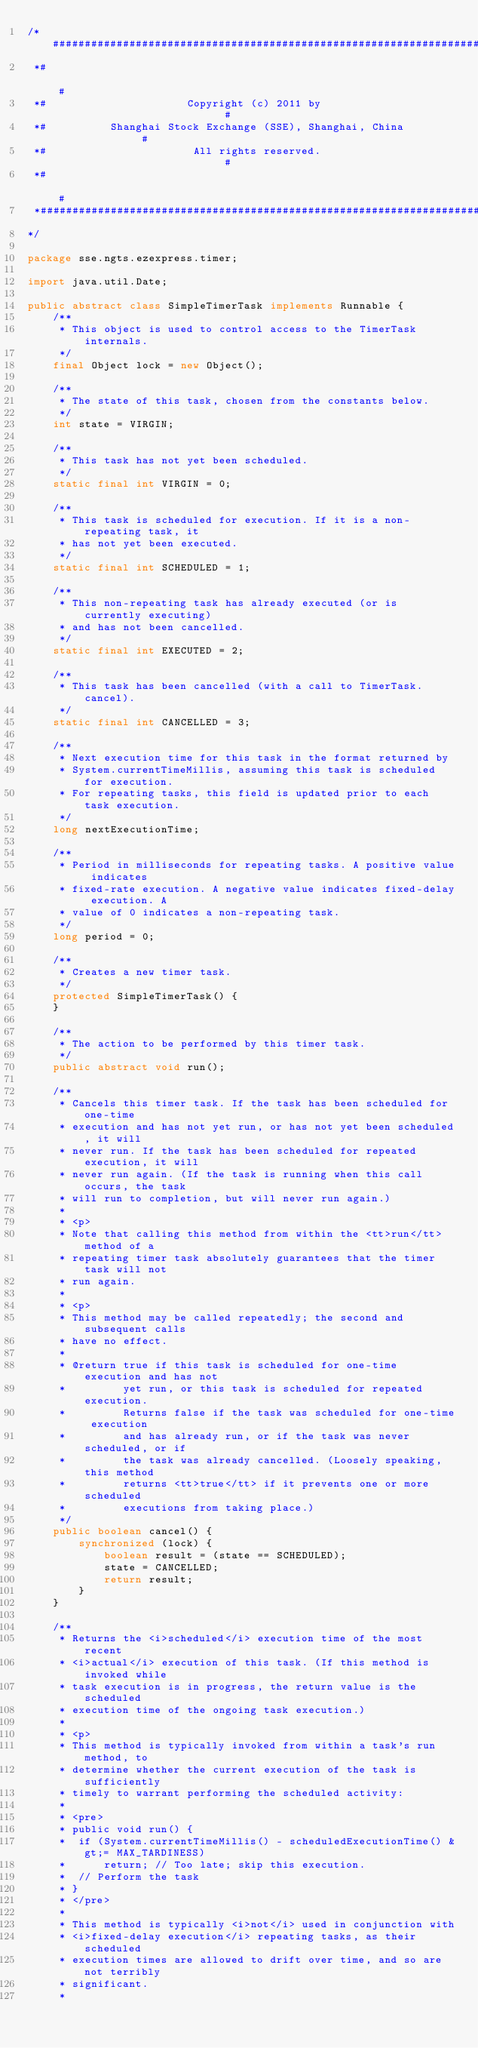<code> <loc_0><loc_0><loc_500><loc_500><_Java_>/*########################################################################
 *#                                                                      #
 *#                      Copyright (c) 2011 by                           #
 *#          Shanghai Stock Exchange (SSE), Shanghai, China              #
 *#                       All rights reserved.                           #
 *#                                                                      #
 *########################################################################
*/

package sse.ngts.ezexpress.timer;

import java.util.Date;

public abstract class SimpleTimerTask implements Runnable {
	/**
	 * This object is used to control access to the TimerTask internals.
	 */
	final Object lock = new Object();

	/**
	 * The state of this task, chosen from the constants below.
	 */
	int state = VIRGIN;

	/**
	 * This task has not yet been scheduled.
	 */
	static final int VIRGIN = 0;

	/**
	 * This task is scheduled for execution. If it is a non-repeating task, it
	 * has not yet been executed.
	 */
	static final int SCHEDULED = 1;

	/**
	 * This non-repeating task has already executed (or is currently executing)
	 * and has not been cancelled.
	 */
	static final int EXECUTED = 2;

	/**
	 * This task has been cancelled (with a call to TimerTask.cancel).
	 */
	static final int CANCELLED = 3;

	/**
	 * Next execution time for this task in the format returned by
	 * System.currentTimeMillis, assuming this task is scheduled for execution.
	 * For repeating tasks, this field is updated prior to each task execution.
	 */
	long nextExecutionTime;

	/**
	 * Period in milliseconds for repeating tasks. A positive value indicates
	 * fixed-rate execution. A negative value indicates fixed-delay execution. A
	 * value of 0 indicates a non-repeating task.
	 */
	long period = 0;

	/**
	 * Creates a new timer task.
	 */
	protected SimpleTimerTask() {
	}

	/**
	 * The action to be performed by this timer task.
	 */
	public abstract void run();

	/**
	 * Cancels this timer task. If the task has been scheduled for one-time
	 * execution and has not yet run, or has not yet been scheduled, it will
	 * never run. If the task has been scheduled for repeated execution, it will
	 * never run again. (If the task is running when this call occurs, the task
	 * will run to completion, but will never run again.)
	 * 
	 * <p>
	 * Note that calling this method from within the <tt>run</tt> method of a
	 * repeating timer task absolutely guarantees that the timer task will not
	 * run again.
	 * 
	 * <p>
	 * This method may be called repeatedly; the second and subsequent calls
	 * have no effect.
	 * 
	 * @return true if this task is scheduled for one-time execution and has not
	 *         yet run, or this task is scheduled for repeated execution.
	 *         Returns false if the task was scheduled for one-time execution
	 *         and has already run, or if the task was never scheduled, or if
	 *         the task was already cancelled. (Loosely speaking, this method
	 *         returns <tt>true</tt> if it prevents one or more scheduled
	 *         executions from taking place.)
	 */
	public boolean cancel() {
		synchronized (lock) {
			boolean result = (state == SCHEDULED);
			state = CANCELLED;
			return result;
		}
	}

	/**
	 * Returns the <i>scheduled</i> execution time of the most recent
	 * <i>actual</i> execution of this task. (If this method is invoked while
	 * task execution is in progress, the return value is the scheduled
	 * execution time of the ongoing task execution.)
	 * 
	 * <p>
	 * This method is typically invoked from within a task's run method, to
	 * determine whether the current execution of the task is sufficiently
	 * timely to warrant performing the scheduled activity:
	 * 
	 * <pre>
	 * public void run() {
	 * 	if (System.currentTimeMillis() - scheduledExecutionTime() &gt;= MAX_TARDINESS)
	 * 		return; // Too late; skip this execution.
	 * 	// Perform the task
	 * }
	 * </pre>
	 * 
	 * This method is typically <i>not</i> used in conjunction with
	 * <i>fixed-delay execution</i> repeating tasks, as their scheduled
	 * execution times are allowed to drift over time, and so are not terribly
	 * significant.
	 * </code> 